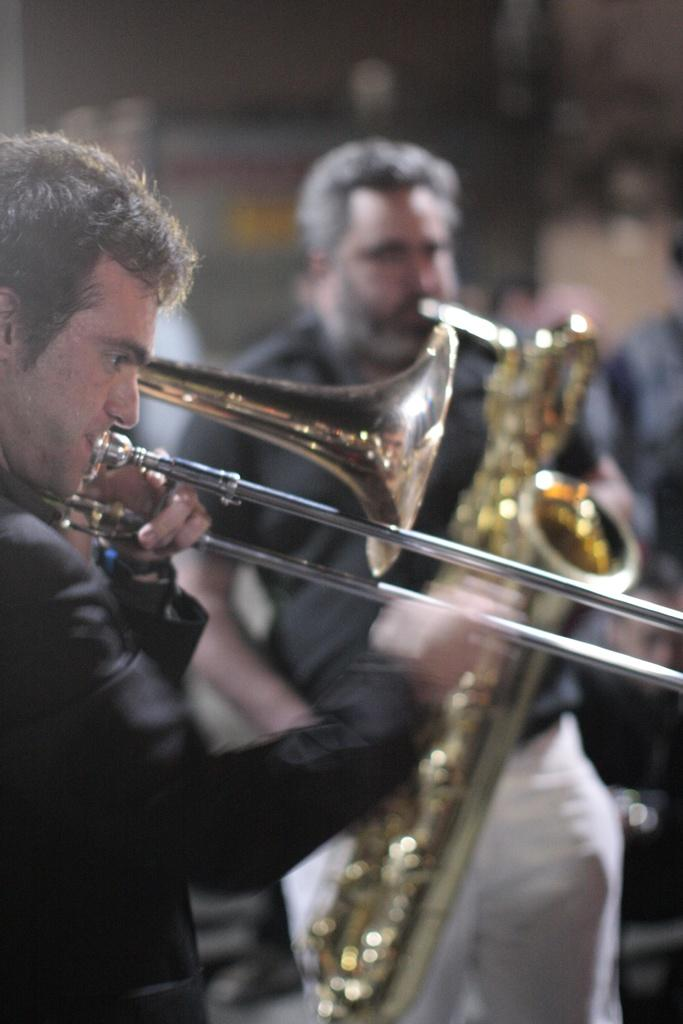What is the man on the left side of the image doing? The man on the left side is playing the trumpet. Can you describe the man in the middle of the image? The man in the middle is standing and playing a musical instrument. He is wearing a t-shirt and trousers. What type of clothing is the man in the middle wearing on his upper body? The man in the middle is wearing a t-shirt. What type of clothing is the man in the middle wearing on his lower body? The man in the middle is wearing trousers. Is there a veil covering the man in the middle's face in the image? No, there is no veil present in the image, and the man in the middle's face is not covered. Can you tell me how many brains are visible in the image? There are no brains visible in the image; it features two men playing musical instruments. 